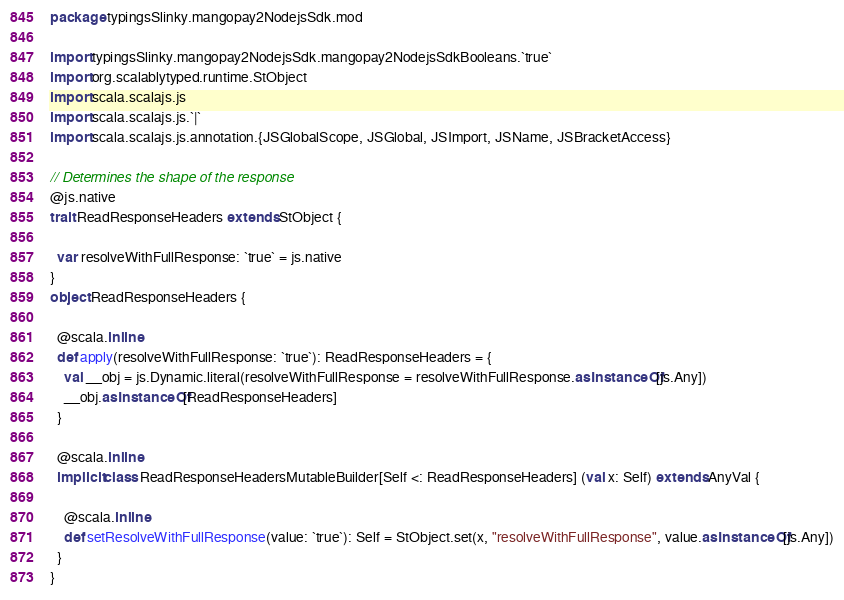<code> <loc_0><loc_0><loc_500><loc_500><_Scala_>package typingsSlinky.mangopay2NodejsSdk.mod

import typingsSlinky.mangopay2NodejsSdk.mangopay2NodejsSdkBooleans.`true`
import org.scalablytyped.runtime.StObject
import scala.scalajs.js
import scala.scalajs.js.`|`
import scala.scalajs.js.annotation.{JSGlobalScope, JSGlobal, JSImport, JSName, JSBracketAccess}

// Determines the shape of the response
@js.native
trait ReadResponseHeaders extends StObject {
  
  var resolveWithFullResponse: `true` = js.native
}
object ReadResponseHeaders {
  
  @scala.inline
  def apply(resolveWithFullResponse: `true`): ReadResponseHeaders = {
    val __obj = js.Dynamic.literal(resolveWithFullResponse = resolveWithFullResponse.asInstanceOf[js.Any])
    __obj.asInstanceOf[ReadResponseHeaders]
  }
  
  @scala.inline
  implicit class ReadResponseHeadersMutableBuilder[Self <: ReadResponseHeaders] (val x: Self) extends AnyVal {
    
    @scala.inline
    def setResolveWithFullResponse(value: `true`): Self = StObject.set(x, "resolveWithFullResponse", value.asInstanceOf[js.Any])
  }
}
</code> 